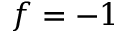Convert formula to latex. <formula><loc_0><loc_0><loc_500><loc_500>f = - 1</formula> 